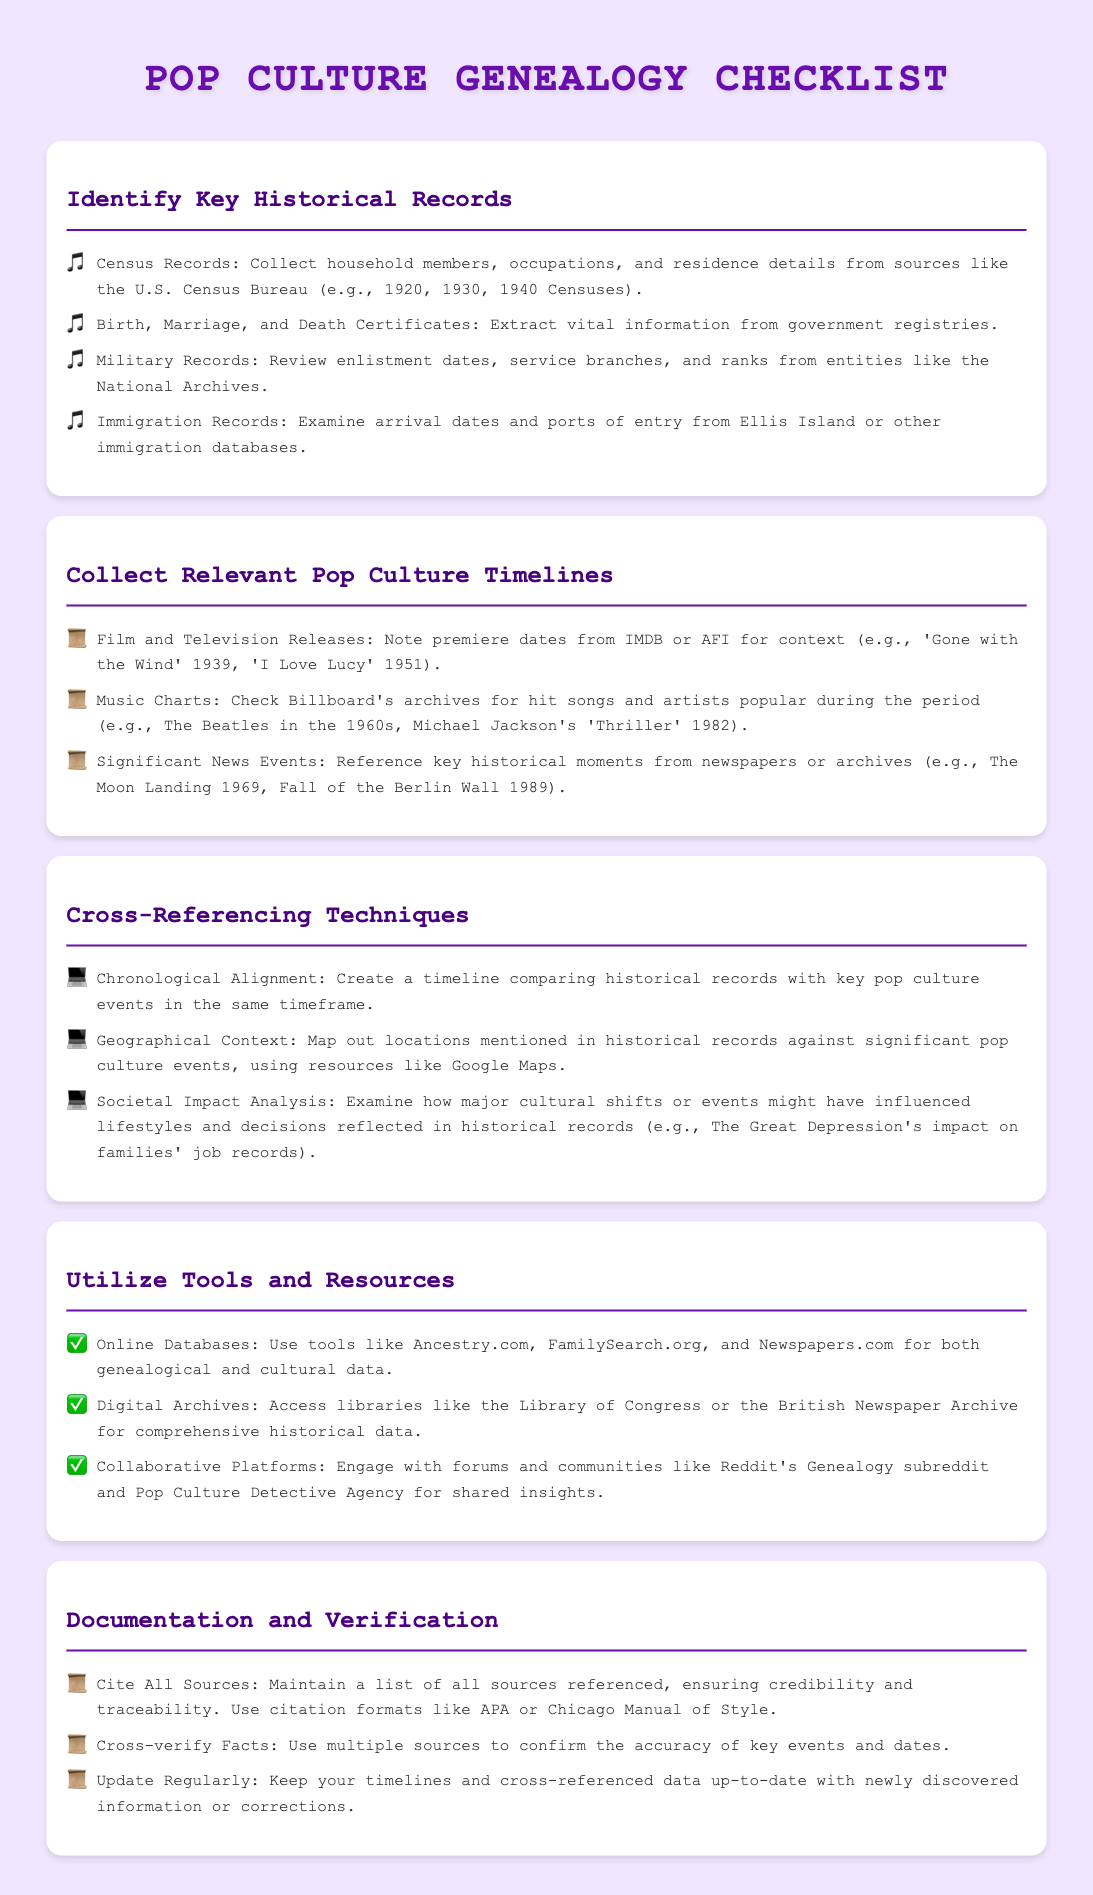What type of records should be identified first? The first section mentions key historical records to identify, such as Census Records, Birth, Marriage, and Death Certificates, Military Records, and Immigration Records.
Answer: Key Historical Records What year did 'Gone with the Wind' premiere? The document lists the film's release date as a key pop culture event, specifically mentioning 'Gone with the Wind' was released in 1939.
Answer: 1939 Which online resource is suggested for genealogical data? The document recommends using online databases like Ancestry.com and FamilySearch.org for genealogical and cultural data.
Answer: Ancestry.com What is one cross-referencing technique mentioned? The document states several techniques, one of which is Chronological Alignment, which involves creating a timeline of events.
Answer: Chronological Alignment What significant news event occurred in 1969? The document mentions the Moon Landing as a significant news event that happened in 1969.
Answer: Moon Landing How should sources be cited according to the checklist? The last section advises maintaining a list of all sources referenced and suggests using citation formats such as APA or Chicago Manual of Style.
Answer: Citation formats like APA What does "Societal Impact Analysis" entail? Societal Impact Analysis examines how cultural shifts affect lifestyles and decisions seen in historical records, as stated in the Cross-Referencing Techniques.
Answer: Cultural shifts Which library is mentioned as a digital archive? The document lists the Library of Congress as a recommended digital archive for accessing historical data.
Answer: Library of Congress 